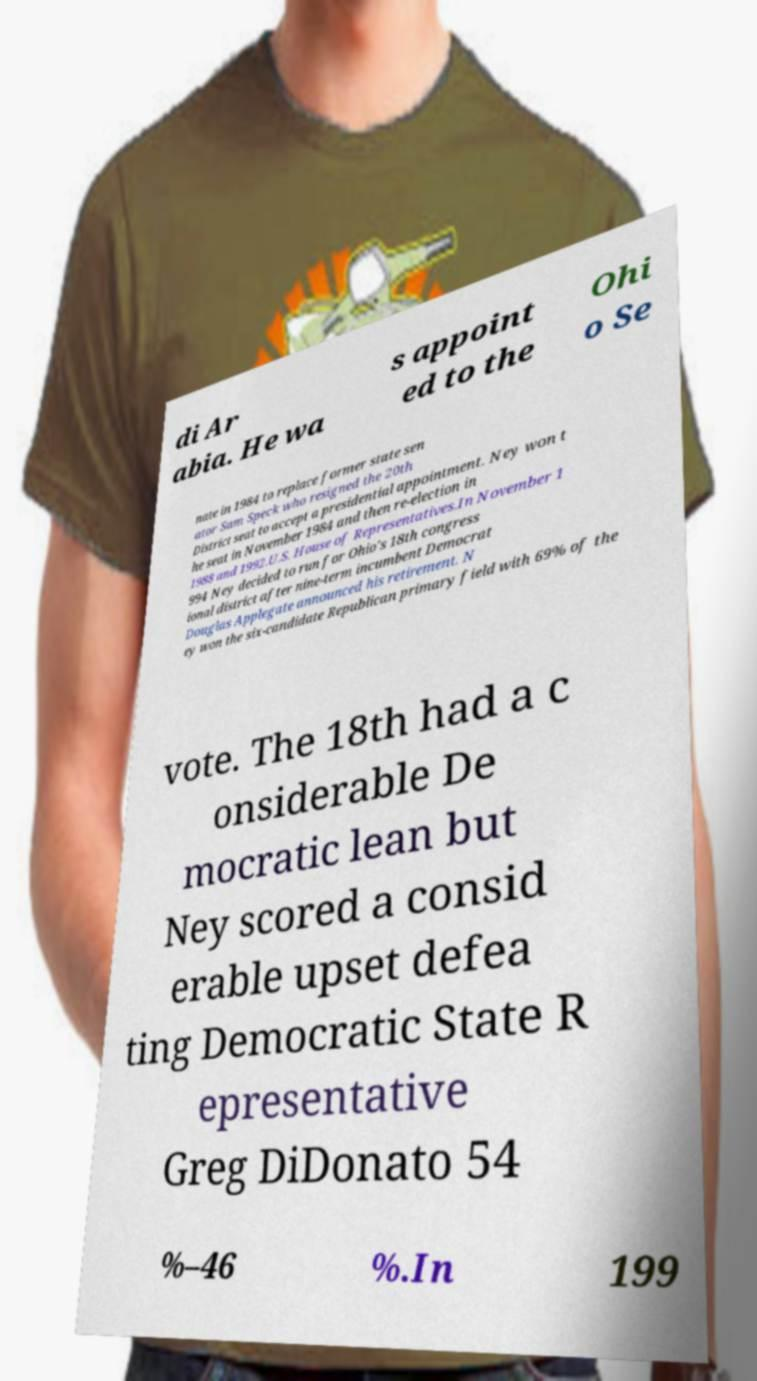What messages or text are displayed in this image? I need them in a readable, typed format. di Ar abia. He wa s appoint ed to the Ohi o Se nate in 1984 to replace former state sen ator Sam Speck who resigned the 20th District seat to accept a presidential appointment. Ney won t he seat in November 1984 and then re-election in 1988 and 1992.U.S. House of Representatives.In November 1 994 Ney decided to run for Ohio's 18th congress ional district after nine-term incumbent Democrat Douglas Applegate announced his retirement. N ey won the six-candidate Republican primary field with 69% of the vote. The 18th had a c onsiderable De mocratic lean but Ney scored a consid erable upset defea ting Democratic State R epresentative Greg DiDonato 54 %–46 %.In 199 